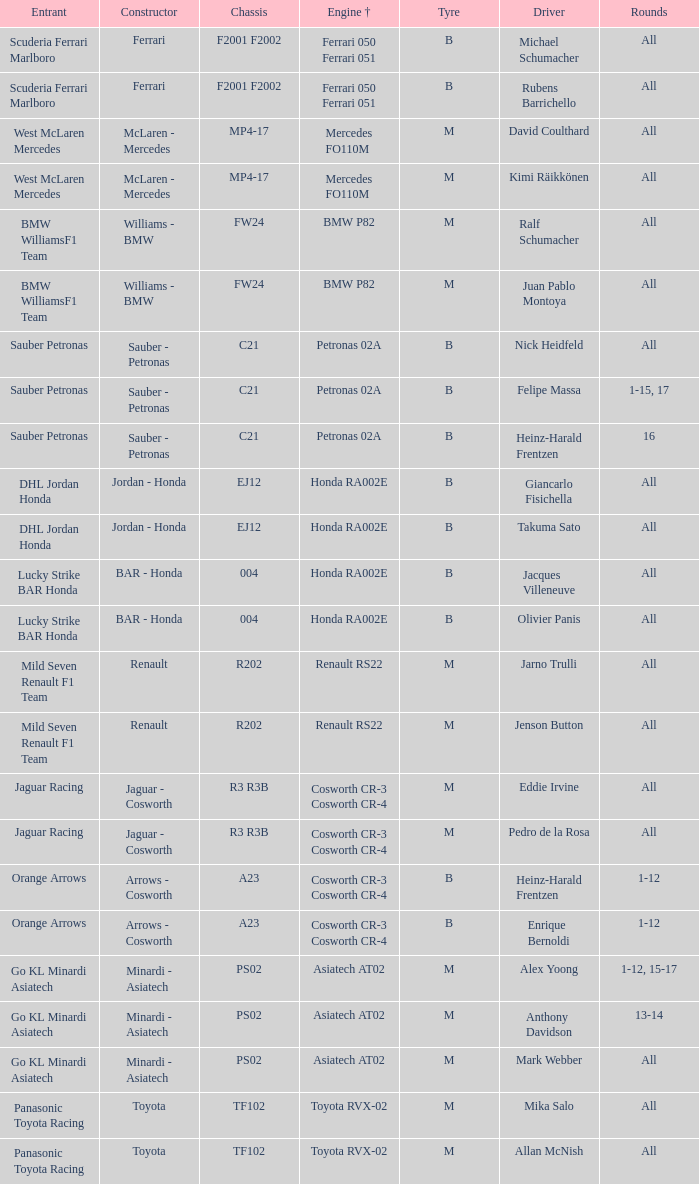What is the tire when the motor is asiatech at02 and the pilot is alex yoong? M. 